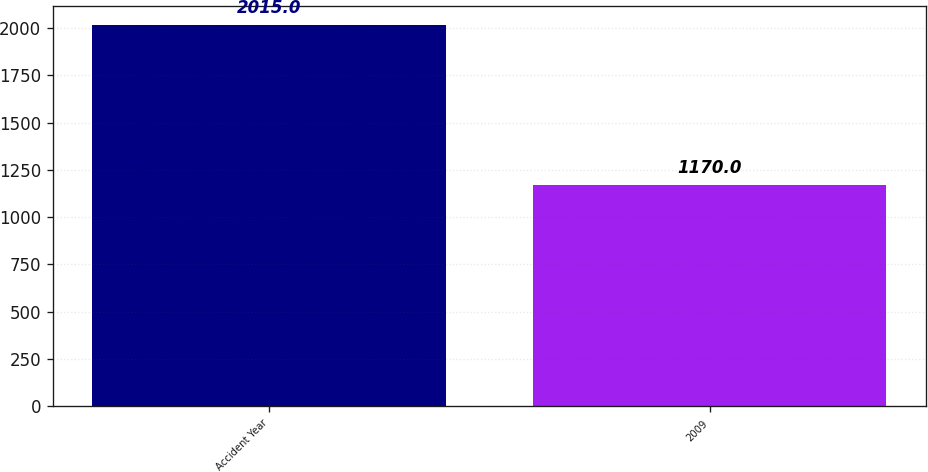Convert chart. <chart><loc_0><loc_0><loc_500><loc_500><bar_chart><fcel>Accident Year<fcel>2009<nl><fcel>2015<fcel>1170<nl></chart> 